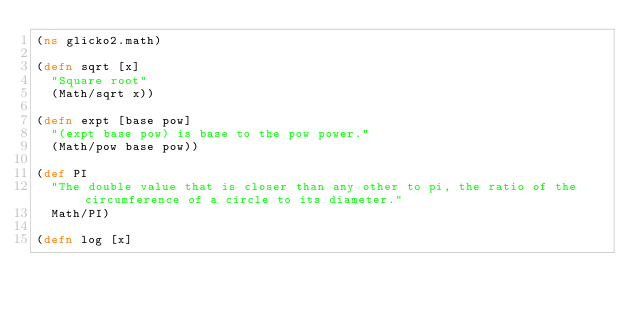Convert code to text. <code><loc_0><loc_0><loc_500><loc_500><_Clojure_>(ns glicko2.math)

(defn sqrt [x]
  "Square root"
  (Math/sqrt x))

(defn expt [base pow]
  "(expt base pow) is base to the pow power."
  (Math/pow base pow))

(def PI
  "The double value that is closer than any other to pi, the ratio of the circumference of a circle to its diameter."
  Math/PI)

(defn log [x]</code> 